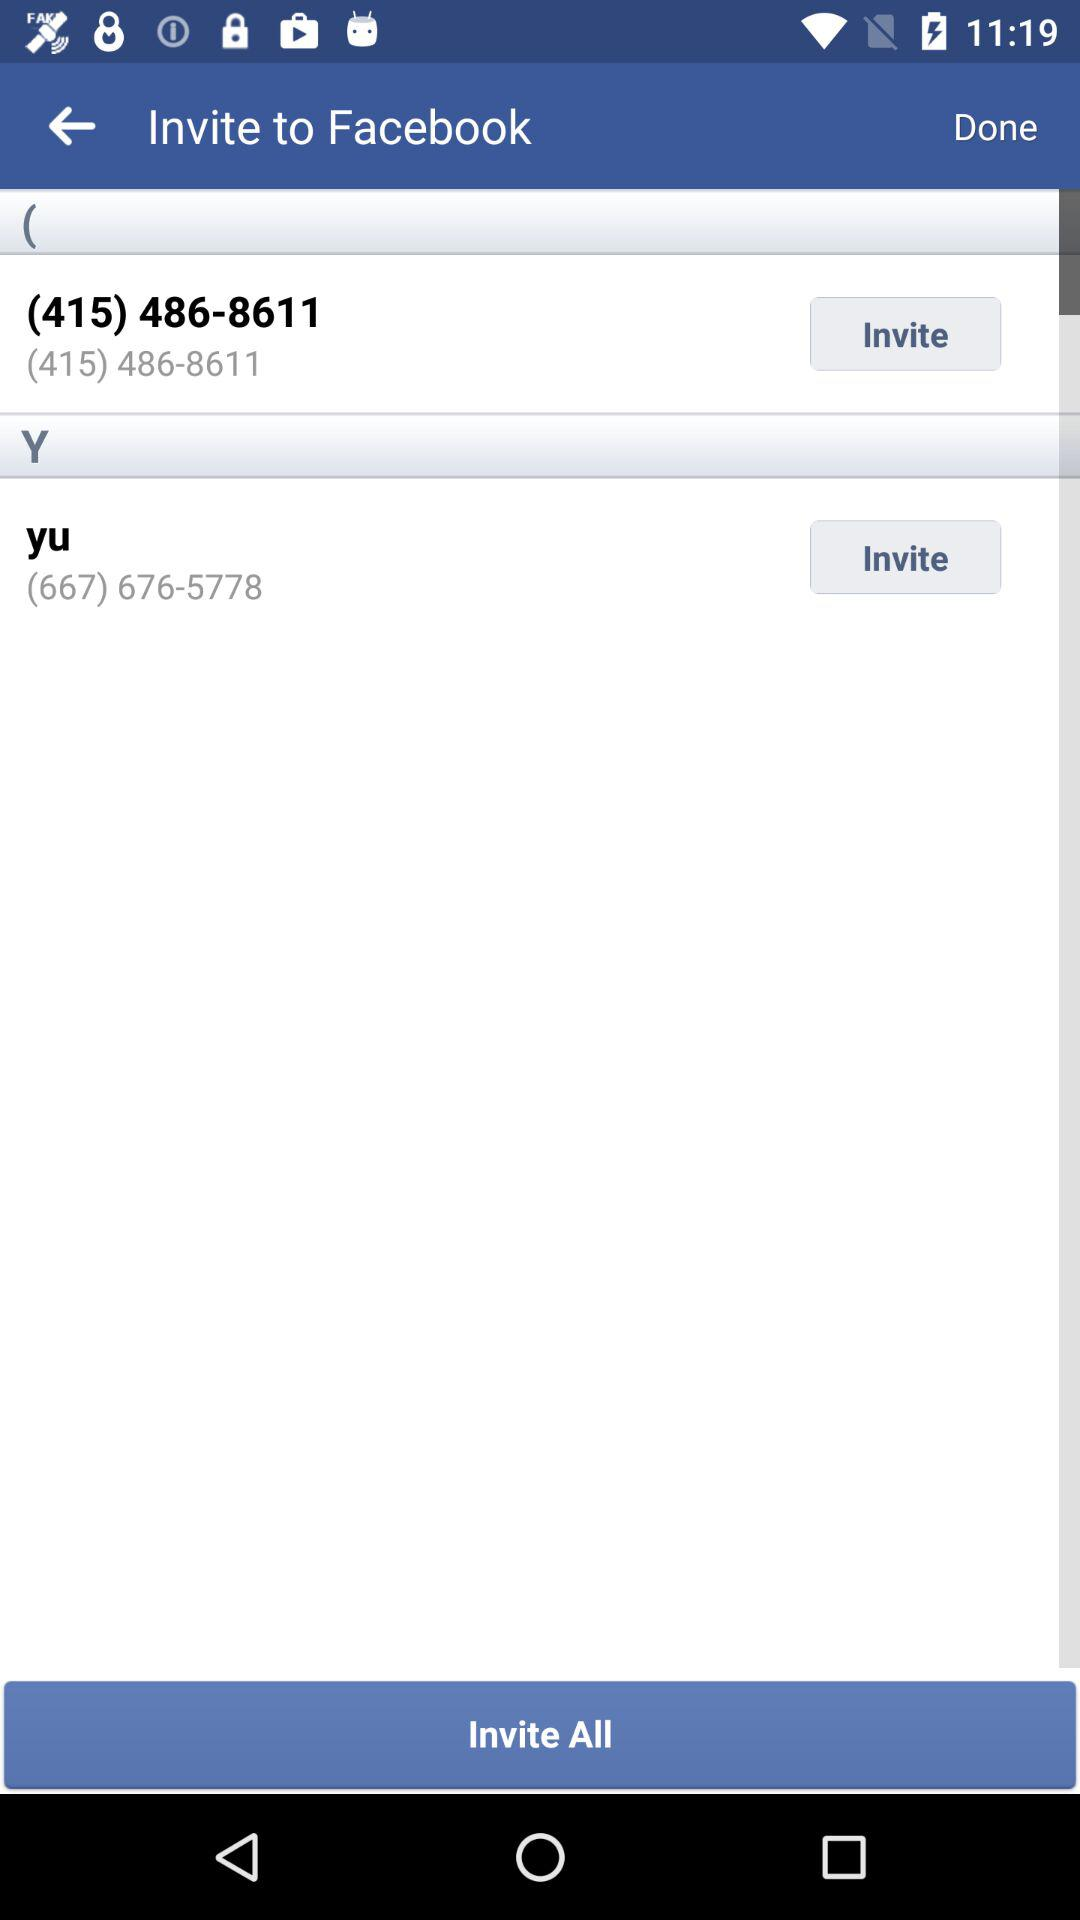What is the contact number of "yu"? The contact number is (667) 676-5778. 